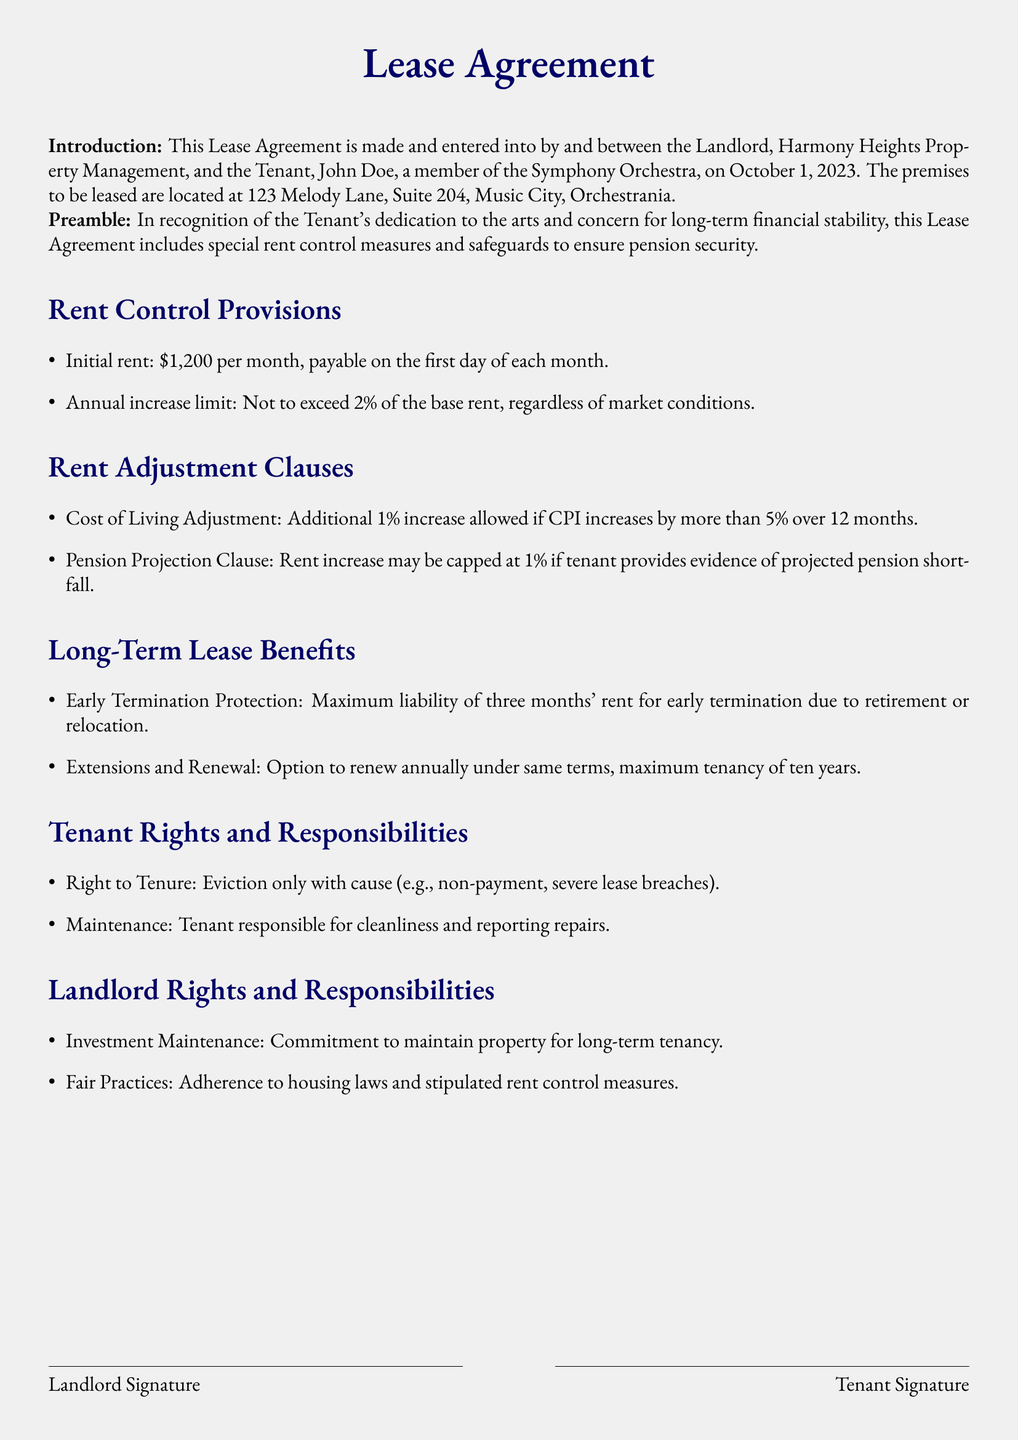What is the initial rent? The initial rent is stated clearly in the document as the amount to be paid monthly at the start of the lease.
Answer: $1,200 What is the maximum annual increase limit? The document specifies the limitations on how much rent can increase each year, ensuring that it does not exceed a certain percentage.
Answer: 2% What factors allow for a Cost of Living Adjustment? The document outlines specific economic indicators that trigger this additional increase, indicating responsiveness to inflation.
Answer: CPI increase over 5% What is the maximum liability for early termination due to retirement? The lease details the financial obligations of the tenant in case of early termination, providing a safeguard for the tenant's finances.
Answer: three months' rent How long is the maximum tenancy allowed under the renewal option? The agreement specifies the length of time that the tenant can renew their lease, which helps them plan for their housing stability.
Answer: ten years What are tenants responsible for regarding maintenance? The lease outlines the general upkeep responsibilities of the tenant, promoting maintenance and care of the property.
Answer: cleanliness and reporting repairs What must the tenant provide to cap rent increase at 1%? The document specifies certain conditions under which the landlord may limit rent increases, ensuring tenant protection in financially tight situations.
Answer: evidence of projected pension shortfall What is the landlord's commitment regarding property maintenance? The lease agreement defines the landlord's obligations towards the property, ensuring it's kept in a state conducive to long-term residence.
Answer: maintain property for long-term tenancy 